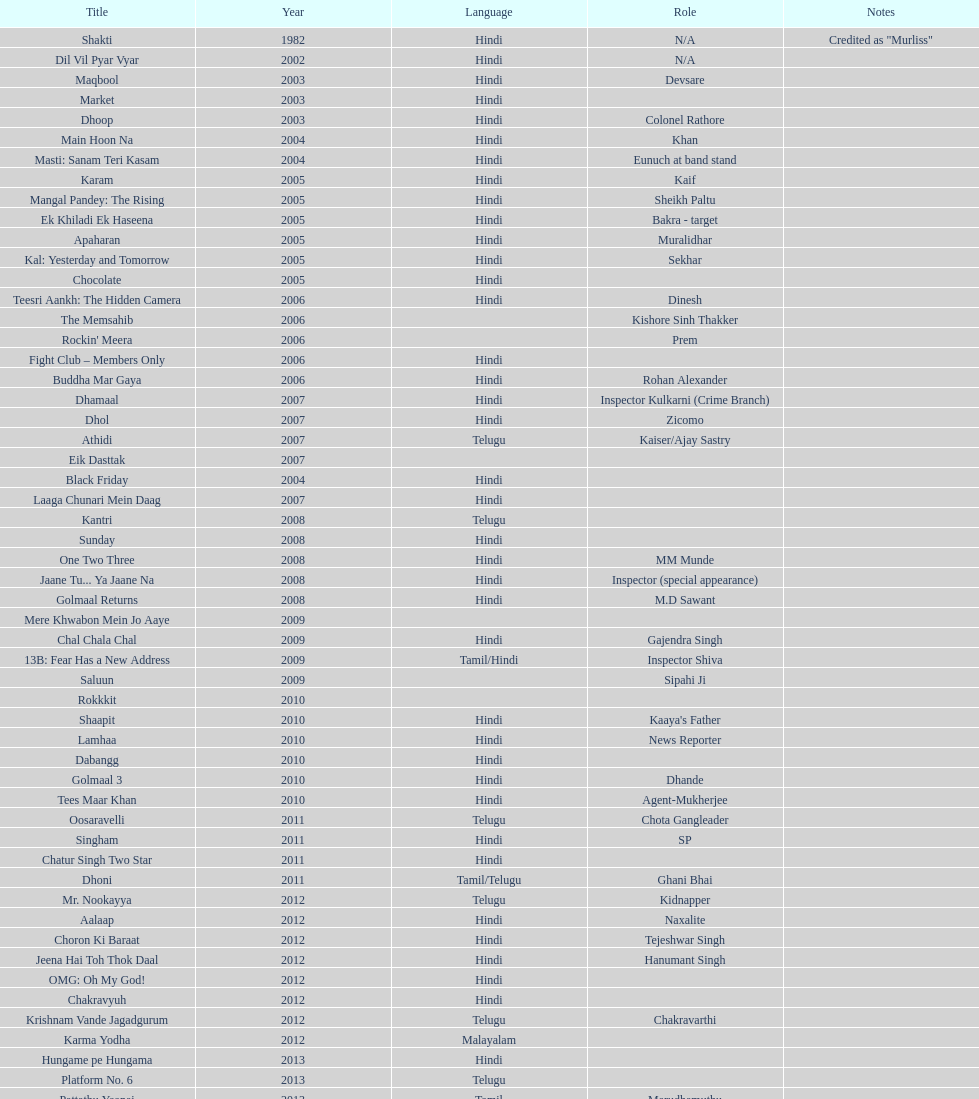In 2005, how many titles were recorded? 6. 